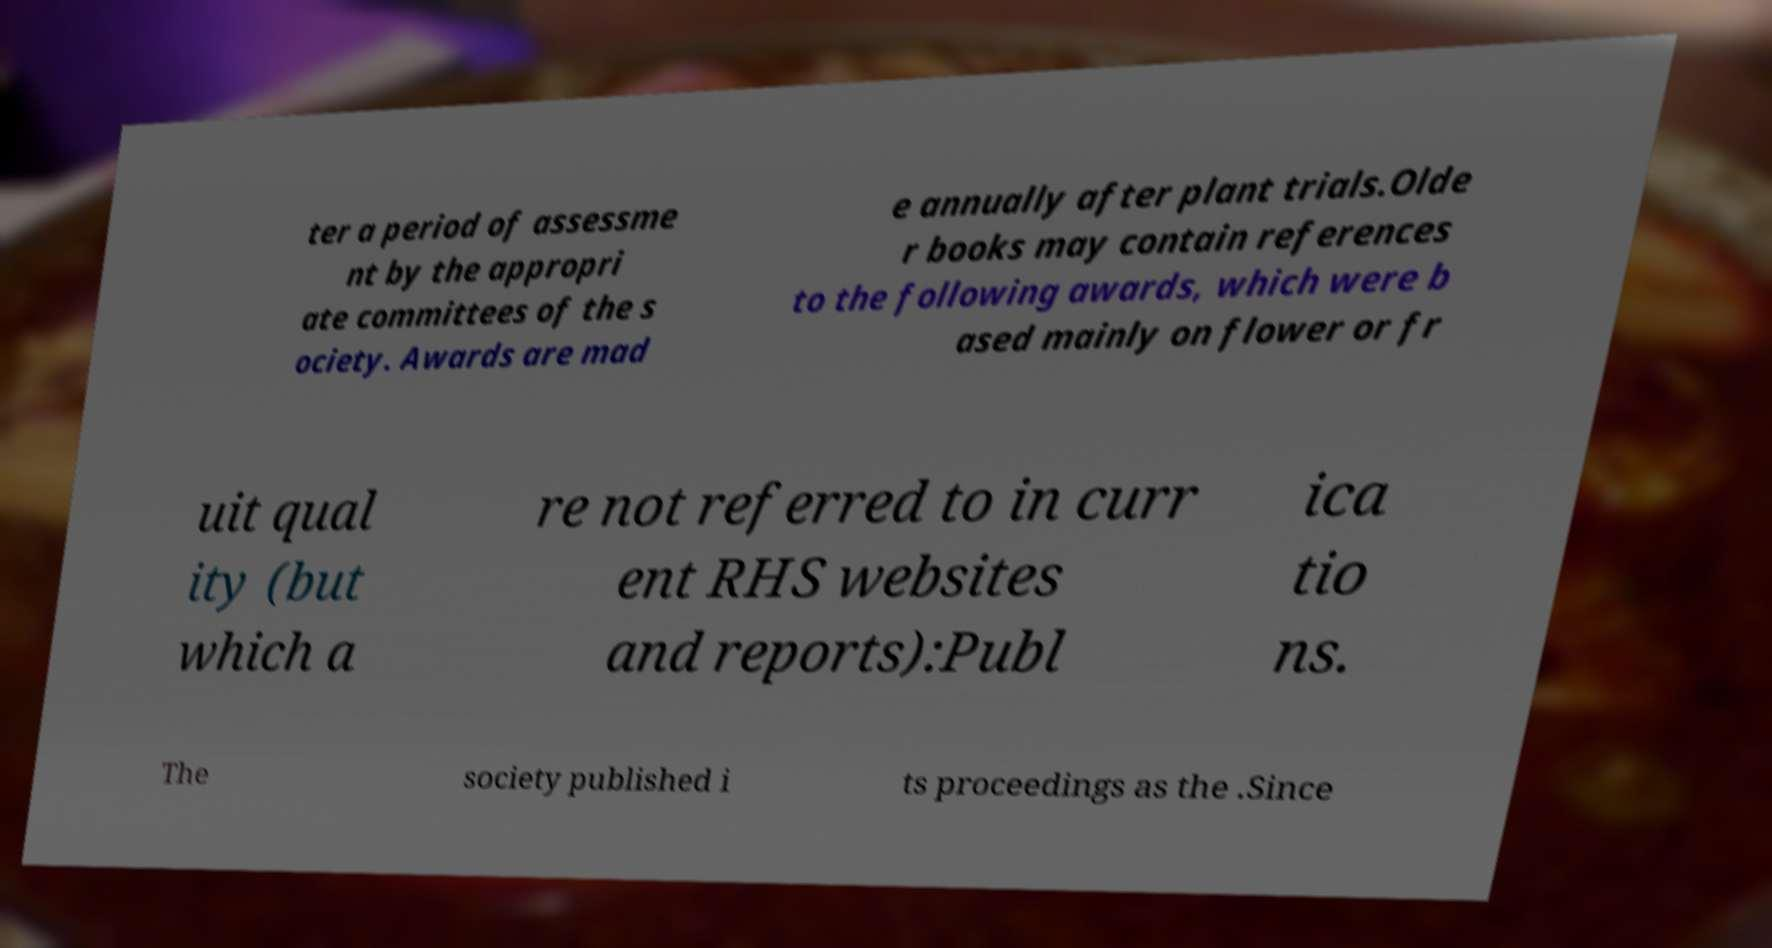For documentation purposes, I need the text within this image transcribed. Could you provide that? ter a period of assessme nt by the appropri ate committees of the s ociety. Awards are mad e annually after plant trials.Olde r books may contain references to the following awards, which were b ased mainly on flower or fr uit qual ity (but which a re not referred to in curr ent RHS websites and reports):Publ ica tio ns. The society published i ts proceedings as the .Since 